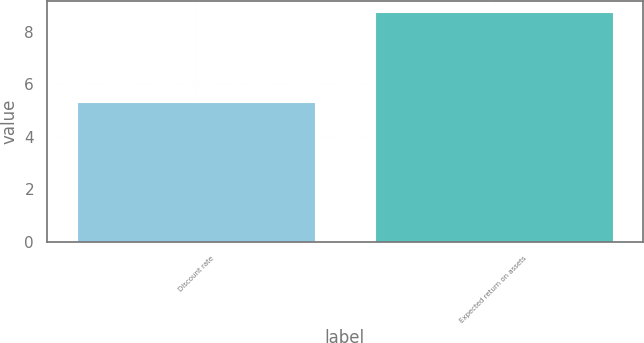<chart> <loc_0><loc_0><loc_500><loc_500><bar_chart><fcel>Discount rate<fcel>Expected return on assets<nl><fcel>5.32<fcel>8.75<nl></chart> 